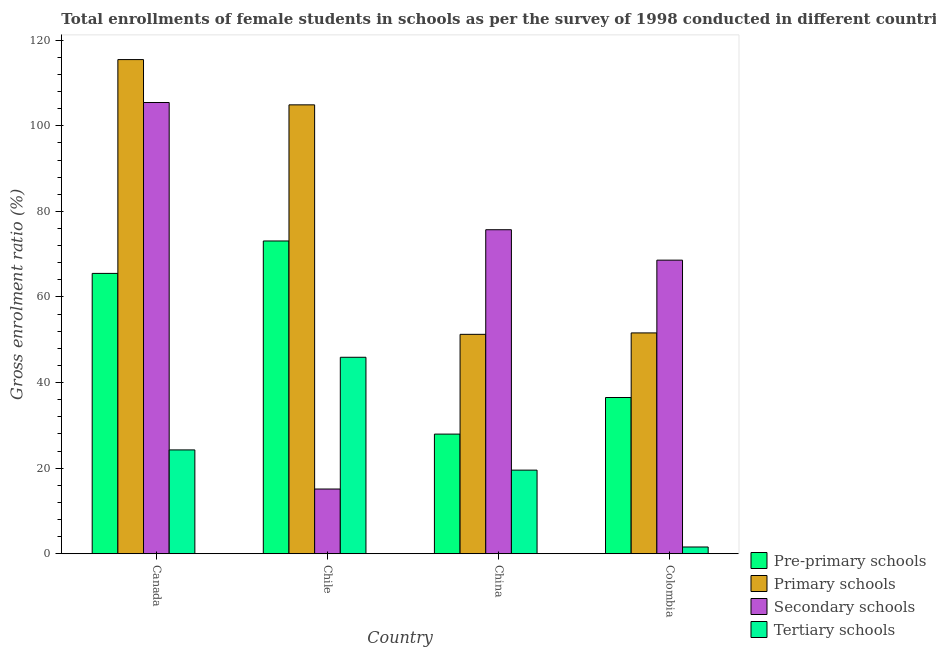How many groups of bars are there?
Give a very brief answer. 4. Are the number of bars per tick equal to the number of legend labels?
Provide a succinct answer. Yes. How many bars are there on the 1st tick from the left?
Offer a very short reply. 4. What is the label of the 4th group of bars from the left?
Keep it short and to the point. Colombia. In how many cases, is the number of bars for a given country not equal to the number of legend labels?
Your answer should be compact. 0. What is the gross enrolment ratio(female) in primary schools in Chile?
Keep it short and to the point. 104.89. Across all countries, what is the maximum gross enrolment ratio(female) in primary schools?
Ensure brevity in your answer.  115.47. Across all countries, what is the minimum gross enrolment ratio(female) in primary schools?
Your answer should be compact. 51.27. In which country was the gross enrolment ratio(female) in tertiary schools maximum?
Your answer should be compact. Chile. What is the total gross enrolment ratio(female) in tertiary schools in the graph?
Your answer should be compact. 91.27. What is the difference between the gross enrolment ratio(female) in tertiary schools in Chile and that in China?
Offer a very short reply. 26.37. What is the difference between the gross enrolment ratio(female) in secondary schools in China and the gross enrolment ratio(female) in primary schools in Canada?
Make the answer very short. -39.76. What is the average gross enrolment ratio(female) in secondary schools per country?
Provide a succinct answer. 66.22. What is the difference between the gross enrolment ratio(female) in tertiary schools and gross enrolment ratio(female) in pre-primary schools in Colombia?
Offer a terse response. -34.93. What is the ratio of the gross enrolment ratio(female) in pre-primary schools in Canada to that in China?
Ensure brevity in your answer.  2.34. Is the gross enrolment ratio(female) in tertiary schools in Canada less than that in China?
Keep it short and to the point. No. Is the difference between the gross enrolment ratio(female) in secondary schools in China and Colombia greater than the difference between the gross enrolment ratio(female) in tertiary schools in China and Colombia?
Keep it short and to the point. No. What is the difference between the highest and the second highest gross enrolment ratio(female) in pre-primary schools?
Offer a terse response. 7.58. What is the difference between the highest and the lowest gross enrolment ratio(female) in primary schools?
Keep it short and to the point. 64.2. Is the sum of the gross enrolment ratio(female) in primary schools in Canada and China greater than the maximum gross enrolment ratio(female) in pre-primary schools across all countries?
Ensure brevity in your answer.  Yes. What does the 2nd bar from the left in Chile represents?
Provide a short and direct response. Primary schools. What does the 4th bar from the right in Colombia represents?
Provide a short and direct response. Pre-primary schools. Is it the case that in every country, the sum of the gross enrolment ratio(female) in pre-primary schools and gross enrolment ratio(female) in primary schools is greater than the gross enrolment ratio(female) in secondary schools?
Provide a succinct answer. Yes. How many bars are there?
Offer a very short reply. 16. Are all the bars in the graph horizontal?
Give a very brief answer. No. How many countries are there in the graph?
Keep it short and to the point. 4. What is the difference between two consecutive major ticks on the Y-axis?
Offer a very short reply. 20. Does the graph contain any zero values?
Offer a very short reply. No. Does the graph contain grids?
Keep it short and to the point. No. Where does the legend appear in the graph?
Provide a short and direct response. Bottom right. How many legend labels are there?
Offer a very short reply. 4. How are the legend labels stacked?
Your answer should be compact. Vertical. What is the title of the graph?
Your answer should be very brief. Total enrollments of female students in schools as per the survey of 1998 conducted in different countries. Does "Labor Taxes" appear as one of the legend labels in the graph?
Offer a very short reply. No. What is the label or title of the X-axis?
Make the answer very short. Country. What is the Gross enrolment ratio (%) in Pre-primary schools in Canada?
Your answer should be very brief. 65.5. What is the Gross enrolment ratio (%) in Primary schools in Canada?
Give a very brief answer. 115.47. What is the Gross enrolment ratio (%) in Secondary schools in Canada?
Ensure brevity in your answer.  105.44. What is the Gross enrolment ratio (%) of Tertiary schools in Canada?
Give a very brief answer. 24.26. What is the Gross enrolment ratio (%) in Pre-primary schools in Chile?
Offer a terse response. 73.08. What is the Gross enrolment ratio (%) of Primary schools in Chile?
Ensure brevity in your answer.  104.89. What is the Gross enrolment ratio (%) of Secondary schools in Chile?
Keep it short and to the point. 15.12. What is the Gross enrolment ratio (%) in Tertiary schools in Chile?
Offer a very short reply. 45.9. What is the Gross enrolment ratio (%) of Pre-primary schools in China?
Your answer should be very brief. 27.95. What is the Gross enrolment ratio (%) in Primary schools in China?
Keep it short and to the point. 51.27. What is the Gross enrolment ratio (%) of Secondary schools in China?
Ensure brevity in your answer.  75.71. What is the Gross enrolment ratio (%) of Tertiary schools in China?
Make the answer very short. 19.53. What is the Gross enrolment ratio (%) of Pre-primary schools in Colombia?
Make the answer very short. 36.5. What is the Gross enrolment ratio (%) of Primary schools in Colombia?
Offer a terse response. 51.6. What is the Gross enrolment ratio (%) of Secondary schools in Colombia?
Your answer should be very brief. 68.6. What is the Gross enrolment ratio (%) of Tertiary schools in Colombia?
Your response must be concise. 1.57. Across all countries, what is the maximum Gross enrolment ratio (%) in Pre-primary schools?
Offer a very short reply. 73.08. Across all countries, what is the maximum Gross enrolment ratio (%) of Primary schools?
Offer a very short reply. 115.47. Across all countries, what is the maximum Gross enrolment ratio (%) of Secondary schools?
Provide a succinct answer. 105.44. Across all countries, what is the maximum Gross enrolment ratio (%) in Tertiary schools?
Offer a terse response. 45.9. Across all countries, what is the minimum Gross enrolment ratio (%) of Pre-primary schools?
Provide a succinct answer. 27.95. Across all countries, what is the minimum Gross enrolment ratio (%) in Primary schools?
Keep it short and to the point. 51.27. Across all countries, what is the minimum Gross enrolment ratio (%) in Secondary schools?
Your answer should be very brief. 15.12. Across all countries, what is the minimum Gross enrolment ratio (%) in Tertiary schools?
Your answer should be very brief. 1.57. What is the total Gross enrolment ratio (%) of Pre-primary schools in the graph?
Keep it short and to the point. 203.04. What is the total Gross enrolment ratio (%) of Primary schools in the graph?
Keep it short and to the point. 323.22. What is the total Gross enrolment ratio (%) in Secondary schools in the graph?
Offer a terse response. 264.86. What is the total Gross enrolment ratio (%) of Tertiary schools in the graph?
Make the answer very short. 91.27. What is the difference between the Gross enrolment ratio (%) in Pre-primary schools in Canada and that in Chile?
Give a very brief answer. -7.58. What is the difference between the Gross enrolment ratio (%) in Primary schools in Canada and that in Chile?
Keep it short and to the point. 10.58. What is the difference between the Gross enrolment ratio (%) in Secondary schools in Canada and that in Chile?
Keep it short and to the point. 90.32. What is the difference between the Gross enrolment ratio (%) in Tertiary schools in Canada and that in Chile?
Ensure brevity in your answer.  -21.65. What is the difference between the Gross enrolment ratio (%) of Pre-primary schools in Canada and that in China?
Your answer should be very brief. 37.55. What is the difference between the Gross enrolment ratio (%) of Primary schools in Canada and that in China?
Your response must be concise. 64.2. What is the difference between the Gross enrolment ratio (%) of Secondary schools in Canada and that in China?
Provide a short and direct response. 29.73. What is the difference between the Gross enrolment ratio (%) in Tertiary schools in Canada and that in China?
Offer a very short reply. 4.72. What is the difference between the Gross enrolment ratio (%) in Pre-primary schools in Canada and that in Colombia?
Make the answer very short. 29. What is the difference between the Gross enrolment ratio (%) of Primary schools in Canada and that in Colombia?
Offer a very short reply. 63.87. What is the difference between the Gross enrolment ratio (%) in Secondary schools in Canada and that in Colombia?
Your answer should be compact. 36.84. What is the difference between the Gross enrolment ratio (%) of Tertiary schools in Canada and that in Colombia?
Your response must be concise. 22.68. What is the difference between the Gross enrolment ratio (%) of Pre-primary schools in Chile and that in China?
Offer a very short reply. 45.13. What is the difference between the Gross enrolment ratio (%) of Primary schools in Chile and that in China?
Ensure brevity in your answer.  53.62. What is the difference between the Gross enrolment ratio (%) of Secondary schools in Chile and that in China?
Offer a very short reply. -60.59. What is the difference between the Gross enrolment ratio (%) in Tertiary schools in Chile and that in China?
Keep it short and to the point. 26.37. What is the difference between the Gross enrolment ratio (%) in Pre-primary schools in Chile and that in Colombia?
Offer a very short reply. 36.58. What is the difference between the Gross enrolment ratio (%) of Primary schools in Chile and that in Colombia?
Your answer should be very brief. 53.29. What is the difference between the Gross enrolment ratio (%) in Secondary schools in Chile and that in Colombia?
Give a very brief answer. -53.48. What is the difference between the Gross enrolment ratio (%) in Tertiary schools in Chile and that in Colombia?
Make the answer very short. 44.33. What is the difference between the Gross enrolment ratio (%) in Pre-primary schools in China and that in Colombia?
Make the answer very short. -8.55. What is the difference between the Gross enrolment ratio (%) of Primary schools in China and that in Colombia?
Your answer should be very brief. -0.33. What is the difference between the Gross enrolment ratio (%) in Secondary schools in China and that in Colombia?
Your answer should be compact. 7.11. What is the difference between the Gross enrolment ratio (%) in Tertiary schools in China and that in Colombia?
Ensure brevity in your answer.  17.96. What is the difference between the Gross enrolment ratio (%) in Pre-primary schools in Canada and the Gross enrolment ratio (%) in Primary schools in Chile?
Offer a terse response. -39.39. What is the difference between the Gross enrolment ratio (%) of Pre-primary schools in Canada and the Gross enrolment ratio (%) of Secondary schools in Chile?
Your answer should be very brief. 50.38. What is the difference between the Gross enrolment ratio (%) in Pre-primary schools in Canada and the Gross enrolment ratio (%) in Tertiary schools in Chile?
Your answer should be compact. 19.6. What is the difference between the Gross enrolment ratio (%) of Primary schools in Canada and the Gross enrolment ratio (%) of Secondary schools in Chile?
Provide a succinct answer. 100.35. What is the difference between the Gross enrolment ratio (%) in Primary schools in Canada and the Gross enrolment ratio (%) in Tertiary schools in Chile?
Offer a very short reply. 69.56. What is the difference between the Gross enrolment ratio (%) in Secondary schools in Canada and the Gross enrolment ratio (%) in Tertiary schools in Chile?
Your answer should be very brief. 59.53. What is the difference between the Gross enrolment ratio (%) of Pre-primary schools in Canada and the Gross enrolment ratio (%) of Primary schools in China?
Offer a very short reply. 14.24. What is the difference between the Gross enrolment ratio (%) in Pre-primary schools in Canada and the Gross enrolment ratio (%) in Secondary schools in China?
Make the answer very short. -10.2. What is the difference between the Gross enrolment ratio (%) of Pre-primary schools in Canada and the Gross enrolment ratio (%) of Tertiary schools in China?
Your answer should be compact. 45.97. What is the difference between the Gross enrolment ratio (%) of Primary schools in Canada and the Gross enrolment ratio (%) of Secondary schools in China?
Provide a short and direct response. 39.76. What is the difference between the Gross enrolment ratio (%) in Primary schools in Canada and the Gross enrolment ratio (%) in Tertiary schools in China?
Make the answer very short. 95.93. What is the difference between the Gross enrolment ratio (%) of Secondary schools in Canada and the Gross enrolment ratio (%) of Tertiary schools in China?
Offer a very short reply. 85.9. What is the difference between the Gross enrolment ratio (%) in Pre-primary schools in Canada and the Gross enrolment ratio (%) in Primary schools in Colombia?
Offer a very short reply. 13.9. What is the difference between the Gross enrolment ratio (%) of Pre-primary schools in Canada and the Gross enrolment ratio (%) of Secondary schools in Colombia?
Make the answer very short. -3.1. What is the difference between the Gross enrolment ratio (%) of Pre-primary schools in Canada and the Gross enrolment ratio (%) of Tertiary schools in Colombia?
Offer a terse response. 63.93. What is the difference between the Gross enrolment ratio (%) of Primary schools in Canada and the Gross enrolment ratio (%) of Secondary schools in Colombia?
Your answer should be compact. 46.87. What is the difference between the Gross enrolment ratio (%) in Primary schools in Canada and the Gross enrolment ratio (%) in Tertiary schools in Colombia?
Make the answer very short. 113.89. What is the difference between the Gross enrolment ratio (%) in Secondary schools in Canada and the Gross enrolment ratio (%) in Tertiary schools in Colombia?
Offer a terse response. 103.86. What is the difference between the Gross enrolment ratio (%) in Pre-primary schools in Chile and the Gross enrolment ratio (%) in Primary schools in China?
Offer a very short reply. 21.81. What is the difference between the Gross enrolment ratio (%) in Pre-primary schools in Chile and the Gross enrolment ratio (%) in Secondary schools in China?
Provide a succinct answer. -2.63. What is the difference between the Gross enrolment ratio (%) in Pre-primary schools in Chile and the Gross enrolment ratio (%) in Tertiary schools in China?
Your answer should be very brief. 53.55. What is the difference between the Gross enrolment ratio (%) of Primary schools in Chile and the Gross enrolment ratio (%) of Secondary schools in China?
Ensure brevity in your answer.  29.18. What is the difference between the Gross enrolment ratio (%) of Primary schools in Chile and the Gross enrolment ratio (%) of Tertiary schools in China?
Your answer should be very brief. 85.36. What is the difference between the Gross enrolment ratio (%) of Secondary schools in Chile and the Gross enrolment ratio (%) of Tertiary schools in China?
Your response must be concise. -4.42. What is the difference between the Gross enrolment ratio (%) of Pre-primary schools in Chile and the Gross enrolment ratio (%) of Primary schools in Colombia?
Ensure brevity in your answer.  21.48. What is the difference between the Gross enrolment ratio (%) in Pre-primary schools in Chile and the Gross enrolment ratio (%) in Secondary schools in Colombia?
Your response must be concise. 4.48. What is the difference between the Gross enrolment ratio (%) in Pre-primary schools in Chile and the Gross enrolment ratio (%) in Tertiary schools in Colombia?
Keep it short and to the point. 71.51. What is the difference between the Gross enrolment ratio (%) in Primary schools in Chile and the Gross enrolment ratio (%) in Secondary schools in Colombia?
Give a very brief answer. 36.29. What is the difference between the Gross enrolment ratio (%) of Primary schools in Chile and the Gross enrolment ratio (%) of Tertiary schools in Colombia?
Ensure brevity in your answer.  103.32. What is the difference between the Gross enrolment ratio (%) of Secondary schools in Chile and the Gross enrolment ratio (%) of Tertiary schools in Colombia?
Provide a short and direct response. 13.54. What is the difference between the Gross enrolment ratio (%) in Pre-primary schools in China and the Gross enrolment ratio (%) in Primary schools in Colombia?
Your answer should be compact. -23.65. What is the difference between the Gross enrolment ratio (%) of Pre-primary schools in China and the Gross enrolment ratio (%) of Secondary schools in Colombia?
Your answer should be very brief. -40.65. What is the difference between the Gross enrolment ratio (%) in Pre-primary schools in China and the Gross enrolment ratio (%) in Tertiary schools in Colombia?
Keep it short and to the point. 26.38. What is the difference between the Gross enrolment ratio (%) in Primary schools in China and the Gross enrolment ratio (%) in Secondary schools in Colombia?
Give a very brief answer. -17.33. What is the difference between the Gross enrolment ratio (%) in Primary schools in China and the Gross enrolment ratio (%) in Tertiary schools in Colombia?
Your response must be concise. 49.69. What is the difference between the Gross enrolment ratio (%) in Secondary schools in China and the Gross enrolment ratio (%) in Tertiary schools in Colombia?
Your answer should be compact. 74.13. What is the average Gross enrolment ratio (%) of Pre-primary schools per country?
Make the answer very short. 50.76. What is the average Gross enrolment ratio (%) in Primary schools per country?
Keep it short and to the point. 80.81. What is the average Gross enrolment ratio (%) of Secondary schools per country?
Give a very brief answer. 66.22. What is the average Gross enrolment ratio (%) in Tertiary schools per country?
Offer a terse response. 22.82. What is the difference between the Gross enrolment ratio (%) in Pre-primary schools and Gross enrolment ratio (%) in Primary schools in Canada?
Provide a succinct answer. -49.96. What is the difference between the Gross enrolment ratio (%) of Pre-primary schools and Gross enrolment ratio (%) of Secondary schools in Canada?
Your answer should be very brief. -39.93. What is the difference between the Gross enrolment ratio (%) of Pre-primary schools and Gross enrolment ratio (%) of Tertiary schools in Canada?
Ensure brevity in your answer.  41.25. What is the difference between the Gross enrolment ratio (%) in Primary schools and Gross enrolment ratio (%) in Secondary schools in Canada?
Give a very brief answer. 10.03. What is the difference between the Gross enrolment ratio (%) of Primary schools and Gross enrolment ratio (%) of Tertiary schools in Canada?
Ensure brevity in your answer.  91.21. What is the difference between the Gross enrolment ratio (%) of Secondary schools and Gross enrolment ratio (%) of Tertiary schools in Canada?
Make the answer very short. 81.18. What is the difference between the Gross enrolment ratio (%) in Pre-primary schools and Gross enrolment ratio (%) in Primary schools in Chile?
Offer a very short reply. -31.81. What is the difference between the Gross enrolment ratio (%) of Pre-primary schools and Gross enrolment ratio (%) of Secondary schools in Chile?
Give a very brief answer. 57.96. What is the difference between the Gross enrolment ratio (%) in Pre-primary schools and Gross enrolment ratio (%) in Tertiary schools in Chile?
Give a very brief answer. 27.18. What is the difference between the Gross enrolment ratio (%) of Primary schools and Gross enrolment ratio (%) of Secondary schools in Chile?
Provide a succinct answer. 89.77. What is the difference between the Gross enrolment ratio (%) of Primary schools and Gross enrolment ratio (%) of Tertiary schools in Chile?
Give a very brief answer. 58.98. What is the difference between the Gross enrolment ratio (%) in Secondary schools and Gross enrolment ratio (%) in Tertiary schools in Chile?
Provide a succinct answer. -30.79. What is the difference between the Gross enrolment ratio (%) in Pre-primary schools and Gross enrolment ratio (%) in Primary schools in China?
Offer a very short reply. -23.31. What is the difference between the Gross enrolment ratio (%) of Pre-primary schools and Gross enrolment ratio (%) of Secondary schools in China?
Provide a short and direct response. -47.76. What is the difference between the Gross enrolment ratio (%) in Pre-primary schools and Gross enrolment ratio (%) in Tertiary schools in China?
Your answer should be compact. 8.42. What is the difference between the Gross enrolment ratio (%) in Primary schools and Gross enrolment ratio (%) in Secondary schools in China?
Keep it short and to the point. -24.44. What is the difference between the Gross enrolment ratio (%) in Primary schools and Gross enrolment ratio (%) in Tertiary schools in China?
Your response must be concise. 31.73. What is the difference between the Gross enrolment ratio (%) in Secondary schools and Gross enrolment ratio (%) in Tertiary schools in China?
Your answer should be very brief. 56.17. What is the difference between the Gross enrolment ratio (%) in Pre-primary schools and Gross enrolment ratio (%) in Primary schools in Colombia?
Give a very brief answer. -15.1. What is the difference between the Gross enrolment ratio (%) in Pre-primary schools and Gross enrolment ratio (%) in Secondary schools in Colombia?
Offer a very short reply. -32.1. What is the difference between the Gross enrolment ratio (%) of Pre-primary schools and Gross enrolment ratio (%) of Tertiary schools in Colombia?
Give a very brief answer. 34.93. What is the difference between the Gross enrolment ratio (%) of Primary schools and Gross enrolment ratio (%) of Secondary schools in Colombia?
Keep it short and to the point. -17. What is the difference between the Gross enrolment ratio (%) of Primary schools and Gross enrolment ratio (%) of Tertiary schools in Colombia?
Give a very brief answer. 50.03. What is the difference between the Gross enrolment ratio (%) in Secondary schools and Gross enrolment ratio (%) in Tertiary schools in Colombia?
Offer a terse response. 67.03. What is the ratio of the Gross enrolment ratio (%) of Pre-primary schools in Canada to that in Chile?
Keep it short and to the point. 0.9. What is the ratio of the Gross enrolment ratio (%) of Primary schools in Canada to that in Chile?
Provide a succinct answer. 1.1. What is the ratio of the Gross enrolment ratio (%) in Secondary schools in Canada to that in Chile?
Keep it short and to the point. 6.97. What is the ratio of the Gross enrolment ratio (%) of Tertiary schools in Canada to that in Chile?
Offer a very short reply. 0.53. What is the ratio of the Gross enrolment ratio (%) of Pre-primary schools in Canada to that in China?
Your answer should be compact. 2.34. What is the ratio of the Gross enrolment ratio (%) of Primary schools in Canada to that in China?
Your response must be concise. 2.25. What is the ratio of the Gross enrolment ratio (%) in Secondary schools in Canada to that in China?
Provide a short and direct response. 1.39. What is the ratio of the Gross enrolment ratio (%) in Tertiary schools in Canada to that in China?
Offer a terse response. 1.24. What is the ratio of the Gross enrolment ratio (%) of Pre-primary schools in Canada to that in Colombia?
Provide a short and direct response. 1.79. What is the ratio of the Gross enrolment ratio (%) of Primary schools in Canada to that in Colombia?
Keep it short and to the point. 2.24. What is the ratio of the Gross enrolment ratio (%) in Secondary schools in Canada to that in Colombia?
Keep it short and to the point. 1.54. What is the ratio of the Gross enrolment ratio (%) in Tertiary schools in Canada to that in Colombia?
Provide a succinct answer. 15.42. What is the ratio of the Gross enrolment ratio (%) in Pre-primary schools in Chile to that in China?
Provide a short and direct response. 2.61. What is the ratio of the Gross enrolment ratio (%) of Primary schools in Chile to that in China?
Your response must be concise. 2.05. What is the ratio of the Gross enrolment ratio (%) in Secondary schools in Chile to that in China?
Provide a succinct answer. 0.2. What is the ratio of the Gross enrolment ratio (%) in Tertiary schools in Chile to that in China?
Give a very brief answer. 2.35. What is the ratio of the Gross enrolment ratio (%) of Pre-primary schools in Chile to that in Colombia?
Your answer should be very brief. 2. What is the ratio of the Gross enrolment ratio (%) in Primary schools in Chile to that in Colombia?
Offer a terse response. 2.03. What is the ratio of the Gross enrolment ratio (%) of Secondary schools in Chile to that in Colombia?
Offer a terse response. 0.22. What is the ratio of the Gross enrolment ratio (%) in Tertiary schools in Chile to that in Colombia?
Provide a succinct answer. 29.17. What is the ratio of the Gross enrolment ratio (%) of Pre-primary schools in China to that in Colombia?
Your answer should be very brief. 0.77. What is the ratio of the Gross enrolment ratio (%) in Secondary schools in China to that in Colombia?
Provide a succinct answer. 1.1. What is the ratio of the Gross enrolment ratio (%) in Tertiary schools in China to that in Colombia?
Provide a short and direct response. 12.41. What is the difference between the highest and the second highest Gross enrolment ratio (%) of Pre-primary schools?
Provide a short and direct response. 7.58. What is the difference between the highest and the second highest Gross enrolment ratio (%) of Primary schools?
Provide a succinct answer. 10.58. What is the difference between the highest and the second highest Gross enrolment ratio (%) in Secondary schools?
Ensure brevity in your answer.  29.73. What is the difference between the highest and the second highest Gross enrolment ratio (%) of Tertiary schools?
Keep it short and to the point. 21.65. What is the difference between the highest and the lowest Gross enrolment ratio (%) in Pre-primary schools?
Your answer should be compact. 45.13. What is the difference between the highest and the lowest Gross enrolment ratio (%) in Primary schools?
Provide a short and direct response. 64.2. What is the difference between the highest and the lowest Gross enrolment ratio (%) of Secondary schools?
Give a very brief answer. 90.32. What is the difference between the highest and the lowest Gross enrolment ratio (%) in Tertiary schools?
Your response must be concise. 44.33. 